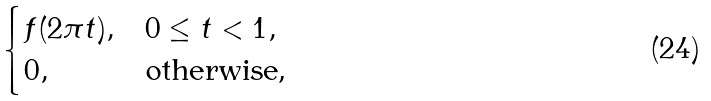Convert formula to latex. <formula><loc_0><loc_0><loc_500><loc_500>\begin{cases} f ( 2 \pi t ) , & 0 \leq t < 1 , \\ 0 , & \text {otherwise,} \end{cases}</formula> 